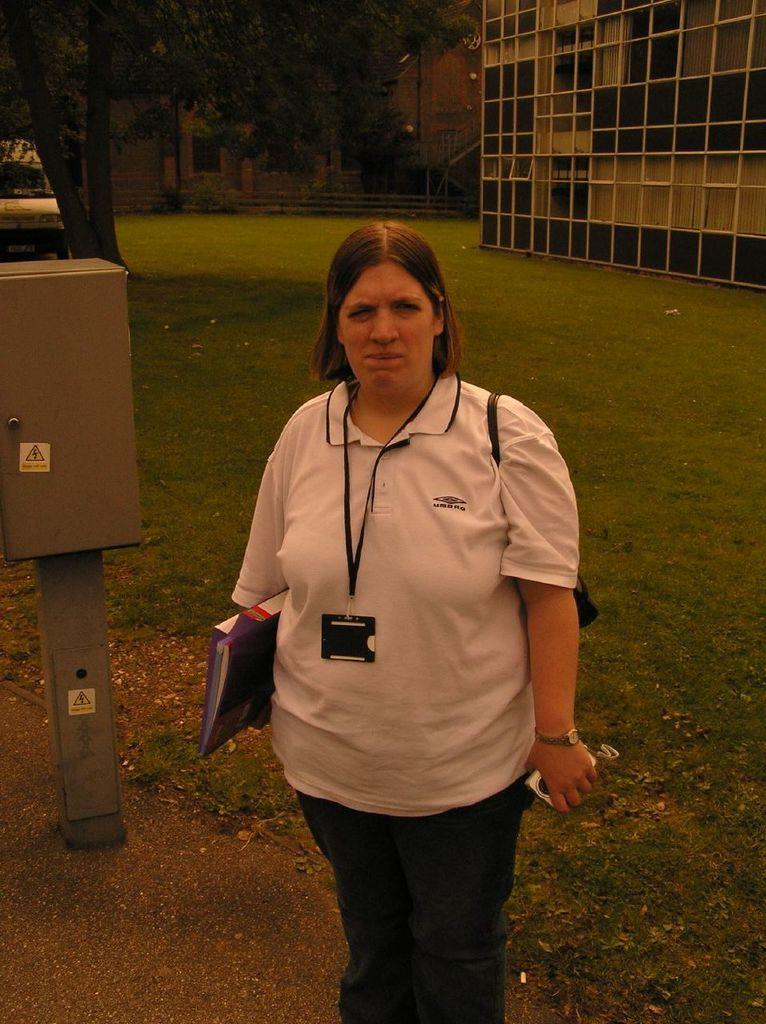Who is the main subject in the image? There is a woman in the image. What is the woman holding in the image? The woman is holding a file. What can be seen in the background of the image? Buildings, trees, a vehicle, and a pole are visible in the background of the image. What type of behavior can be observed in the middle of the image? There is no behavior being observed in the image, as it primarily features a woman holding a file and the background elements. 